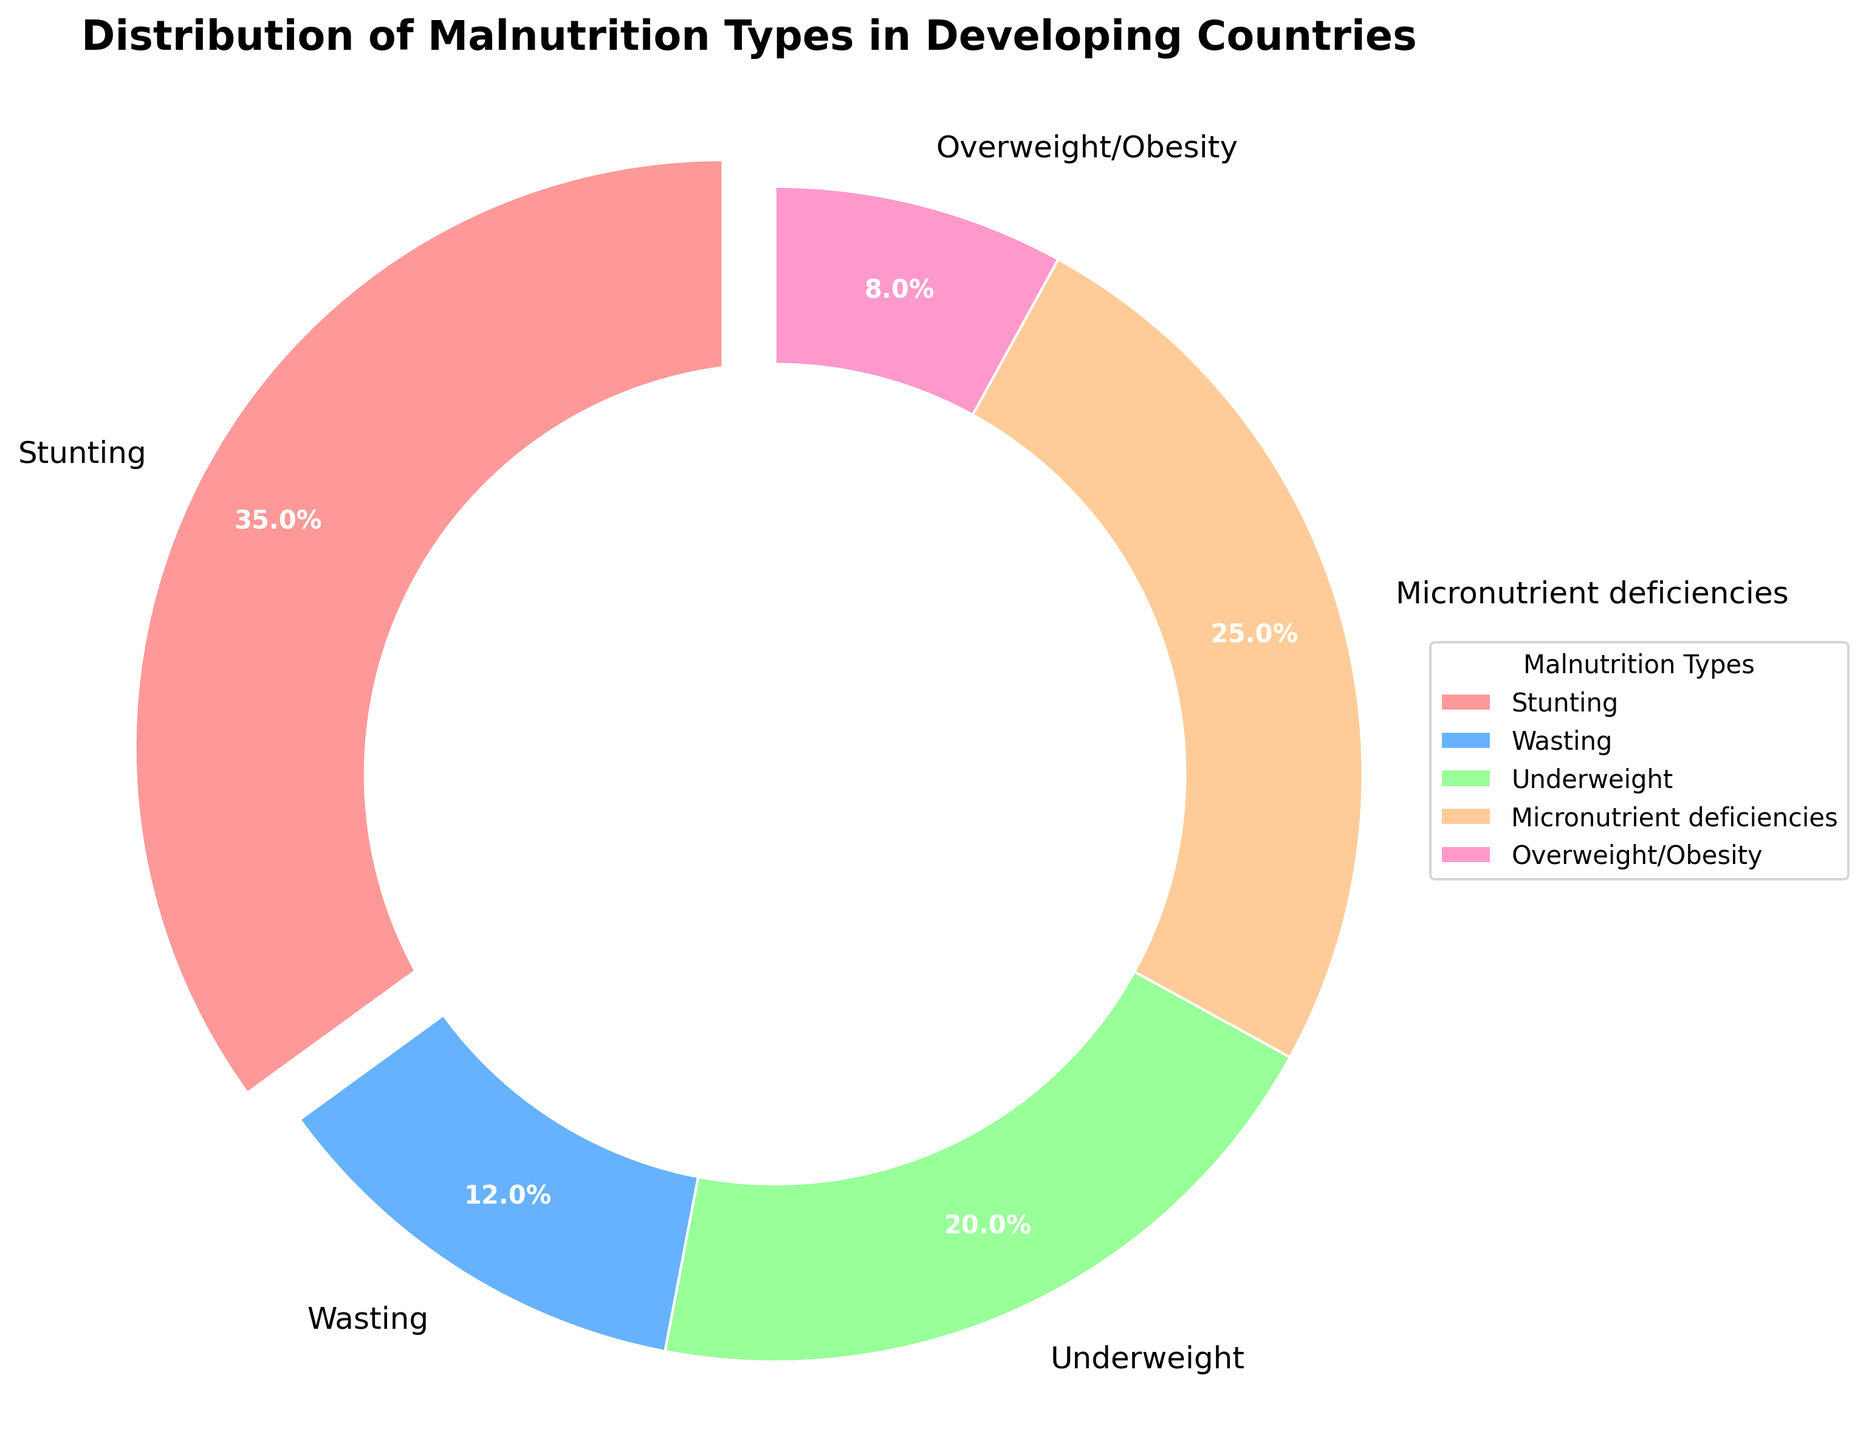What's the most common type of malnutrition in developing countries? Look at the largest segment of the pie chart. The segment labeled "Stunting" is the largest, taking up 35% of the chart.
Answer: Stunting What percentage of the total malnutrition types does wasting represent? Look at the segment of the pie chart labeled "Wasting." It represents 12% of the total malnutrition types.
Answer: 12% How do the percentages of underweight and overweight/obesity compare? Look at the segments labeled "Underweight" and "Overweight/Obesity." Underweight is 20%, while overweight/obesity is 8%. The percentage of underweight is higher.
Answer: Underweight is higher Which malnutrition type is represented by the smallest segment in the pie chart? Look for the smallest segment in the pie chart. The smallest segment is labeled "Overweight/Obesity," which is 8%.
Answer: Overweight/Obesity What is the cumulative percentage of stunting and micronutrient deficiencies? Add the percentages of "Stunting" (35%) and "Micronutrient deficiencies" (25%). 35 + 25 = 60.
Answer: 60% Identify the color associated with wasting in the pie chart. Find the segment labeled "Wasting" and note its color. Wasting is represented in blue.
Answer: Blue How much greater is the percentage of stunting compared to wasting? Subtract the percentage of "Wasting" (12%) from "Stunting" (35%). 35 - 12 = 23.
Answer: 23% What percentage of malnutrition is not due to stunting or wasting? Subtract the percentages of "Stunting" (35%) and "Wasting" (12%) from 100%. 100 - (35 + 12) = 100 - 47 = 53.
Answer: 53% Compare the combined percentage of underweight and micronutrient deficiencies to that of stunting. Which is higher? Add the percentages of "Underweight" (20%) and "Micronutrient deficiencies" (25%). 20 + 25 = 45%. Compare this with "Stunting" which is 35%. 45% is higher than 35%.
Answer: Combined percentage of Underweight and Micronutrient deficiencies What is the average percentage of the five malnutrition types? Add all percentage values and divide by the number of types. (35 + 12 + 20 + 25 + 8) / 5 = 100 / 5 = 20%.
Answer: 20% 